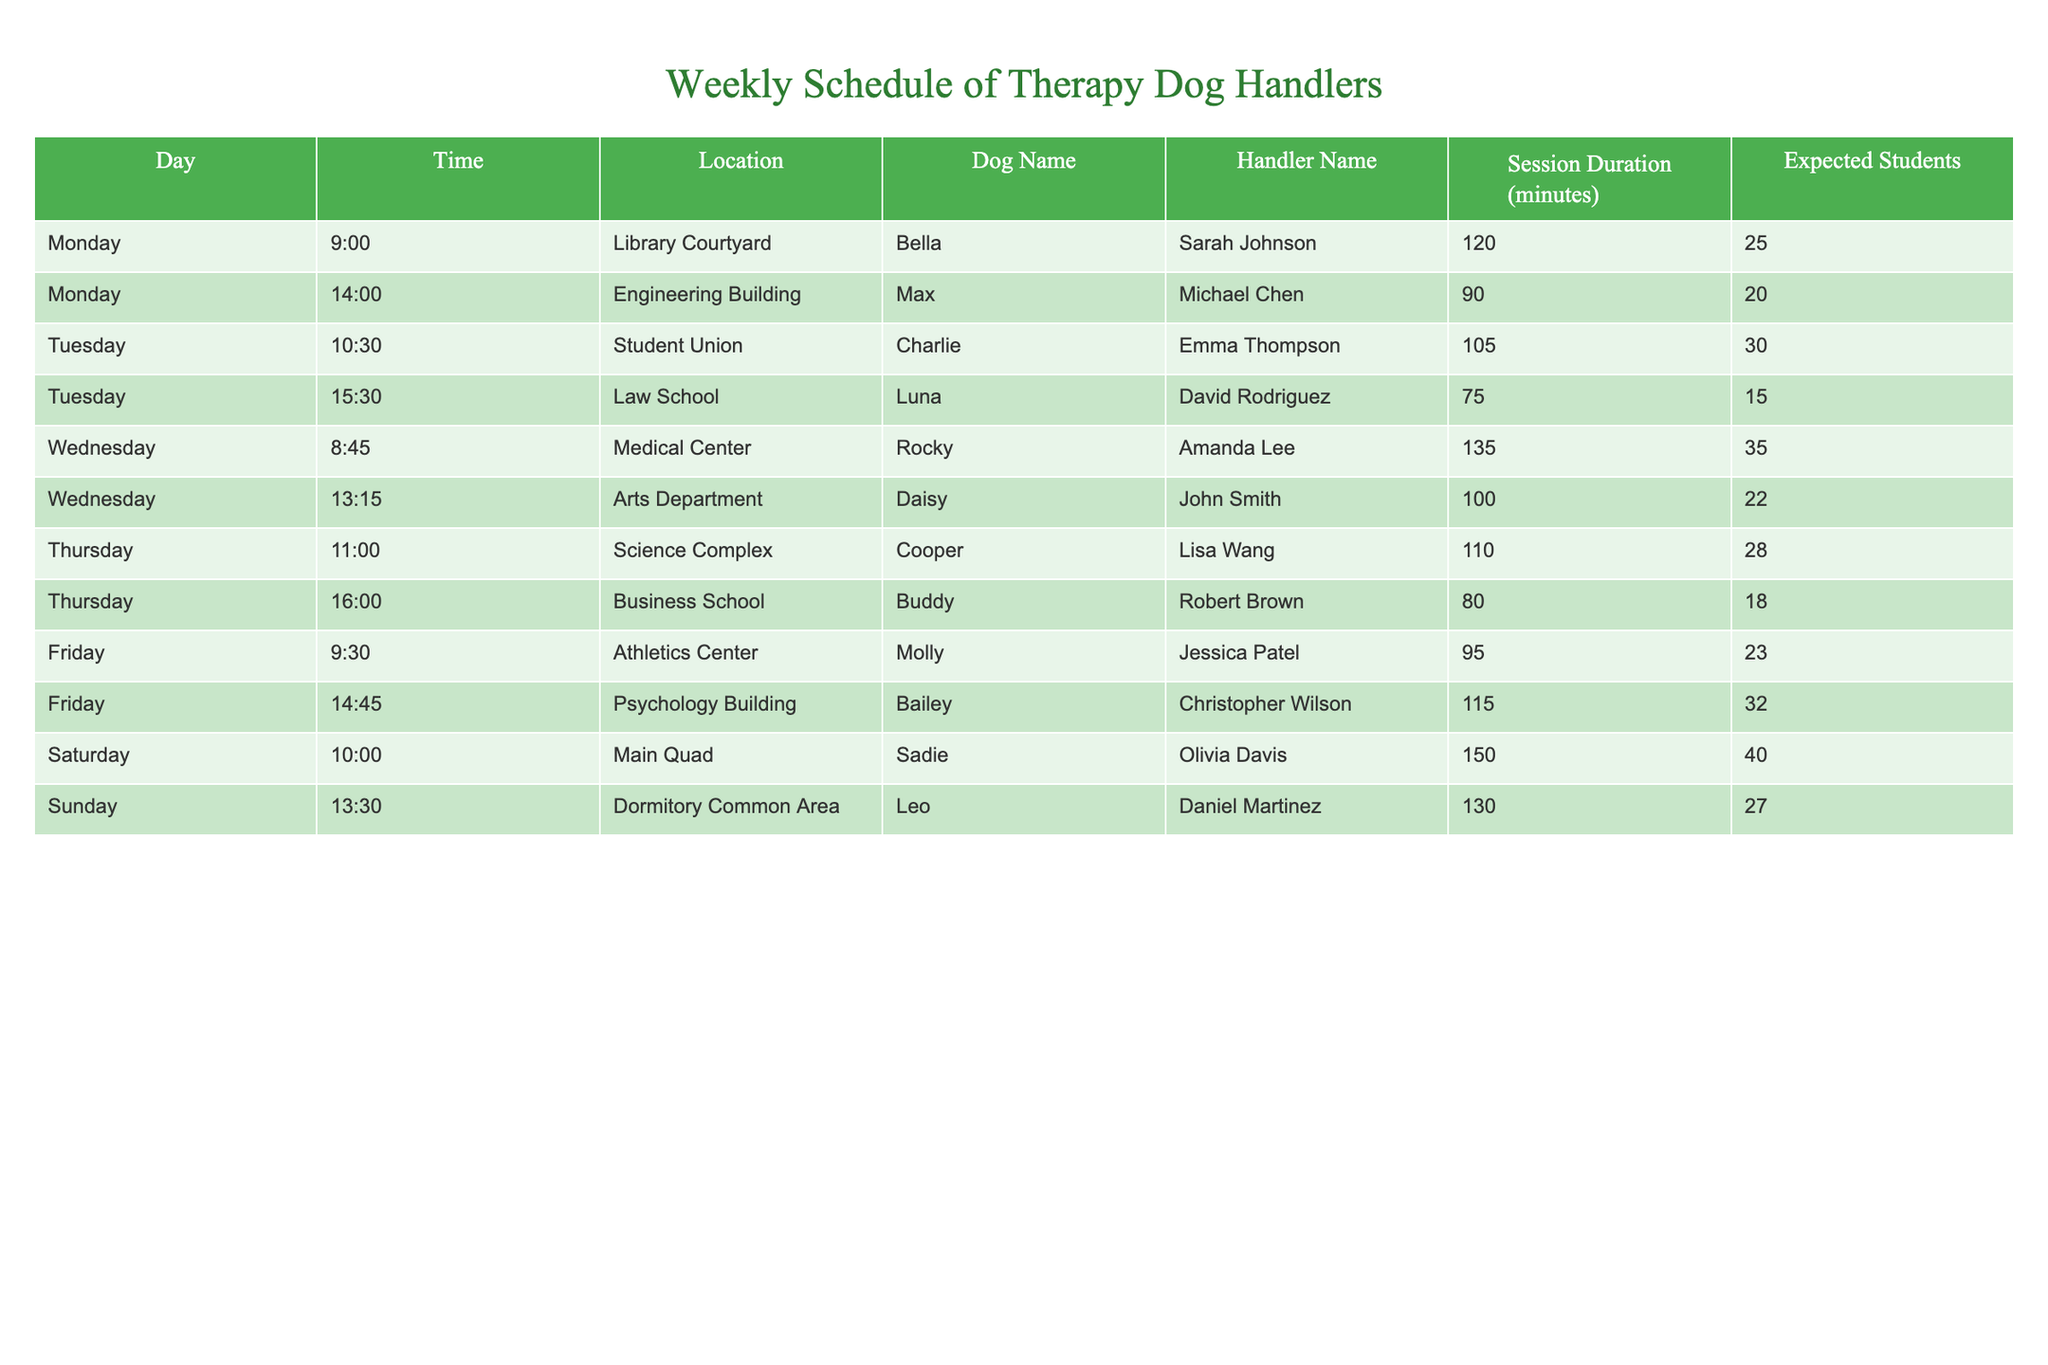What day has the longest therapy dog session? By reviewing the "Session Duration (minutes)" column, the longest session is on Wednesday with Rocky, lasting 135 minutes.
Answer: Wednesday How many total expected students will see therapy dogs on Thursday? Adding the expected students for both sessions on Thursday: 28 (Cooper) + 18 (Buddy) = 46.
Answer: 46 Which location has the most therapy dog sessions in total? By counting the occurrences of each location in the "Location" column, the Student Union has the highest frequency with one session. All locations have only one session each, so they are equal.
Answer: All locations have one session Is there a therapy dog named Bailey? Looking through the "Dog Name" column, Bailey is present, indicating that there is indeed a therapy dog by that name.
Answer: Yes What is the average duration of therapy dog sessions on Mondays? The only two sessions on Monday are 120 minutes for Bella and 90 minutes for Max. The average is (120 + 90) / 2 = 105 minutes.
Answer: 105 Which handler has the highest expected number of students attending their sessions? Comparing the "Expected Students" column, Sadie (Olivia Davis) has the highest at 40 students on Saturday.
Answer: Olivia Davis On which day are sessions scheduled later in the day? Analyzing the times listed, Saturday at 10:00 has the latest morning session, while Monday has sessions until 14:00, indicating that Saturday has later sessions overall.
Answer: Saturday How many therapy dog sessions last 90 minutes or more? Reviewing the duration: Bella (120), Rocky (135), Daisy (100), Cooper (110), Molly (95), Bailey (115), Sadie (150), and Leo (130) - counting these gives us 7 sessions.
Answer: 7 What is the total session duration for the entire week? Adding all session durations: 120 + 90 + 105 + 75 + 135 + 100 + 110 + 80 + 95 + 115 + 150 + 130 = 1,295 minutes for the week.
Answer: 1295 Is Luna's session longer than Charlie's session? Comparing the durations: Luna's session lasts 75 minutes, while Charlie's lasts for 105 minutes. Thus, Charlie's session is longer.
Answer: No 